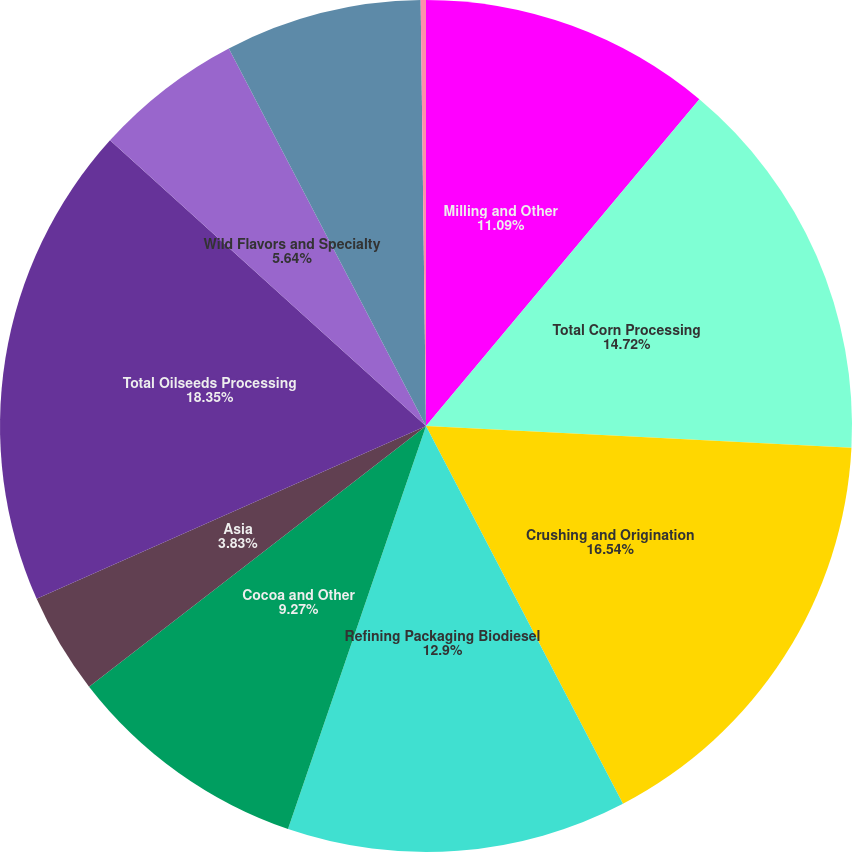<chart> <loc_0><loc_0><loc_500><loc_500><pie_chart><fcel>Milling and Other<fcel>Total Corn Processing<fcel>Crushing and Origination<fcel>Refining Packaging Biodiesel<fcel>Cocoa and Other<fcel>Asia<fcel>Total Oilseeds Processing<fcel>Wild Flavors and Specialty<fcel>Total Wild Flavors and<fcel>Other - Financial<nl><fcel>11.09%<fcel>14.72%<fcel>16.54%<fcel>12.9%<fcel>9.27%<fcel>3.83%<fcel>18.35%<fcel>5.64%<fcel>7.46%<fcel>0.2%<nl></chart> 